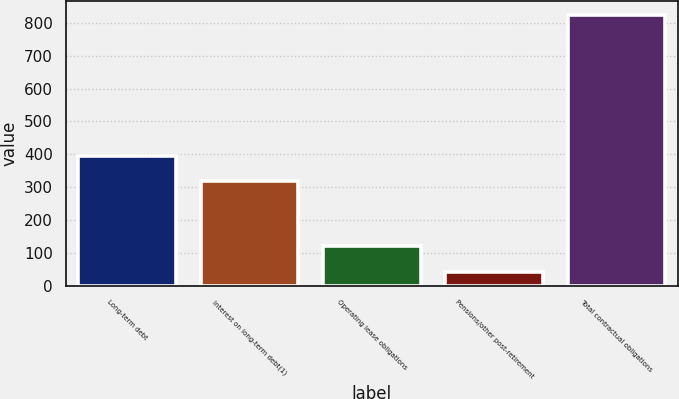<chart> <loc_0><loc_0><loc_500><loc_500><bar_chart><fcel>Long-term debt<fcel>Interest on long-term debt(1)<fcel>Operating lease obligations<fcel>Pensions/other post-retirement<fcel>Total contractual obligations<nl><fcel>396.48<fcel>318.1<fcel>120.18<fcel>41.8<fcel>825.6<nl></chart> 